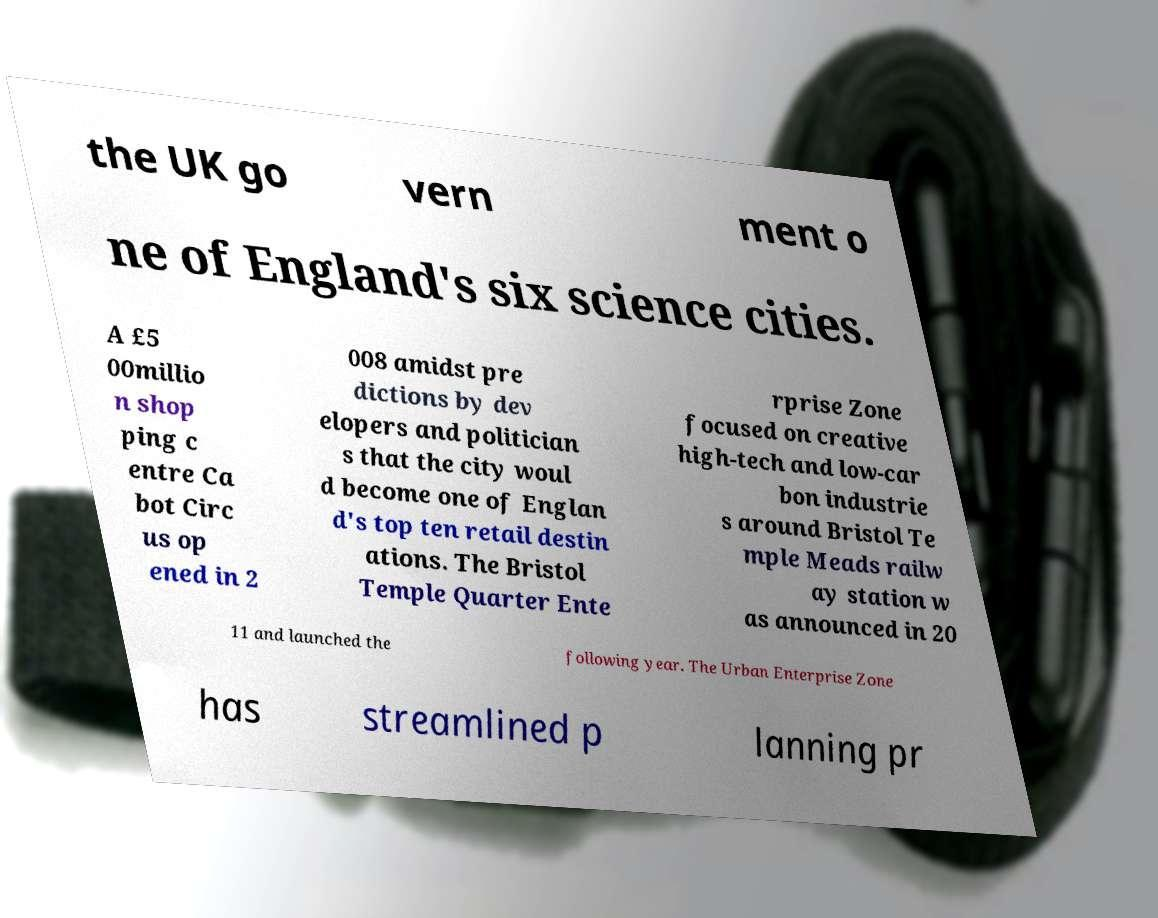Could you extract and type out the text from this image? the UK go vern ment o ne of England's six science cities. A £5 00millio n shop ping c entre Ca bot Circ us op ened in 2 008 amidst pre dictions by dev elopers and politician s that the city woul d become one of Englan d's top ten retail destin ations. The Bristol Temple Quarter Ente rprise Zone focused on creative high-tech and low-car bon industrie s around Bristol Te mple Meads railw ay station w as announced in 20 11 and launched the following year. The Urban Enterprise Zone has streamlined p lanning pr 